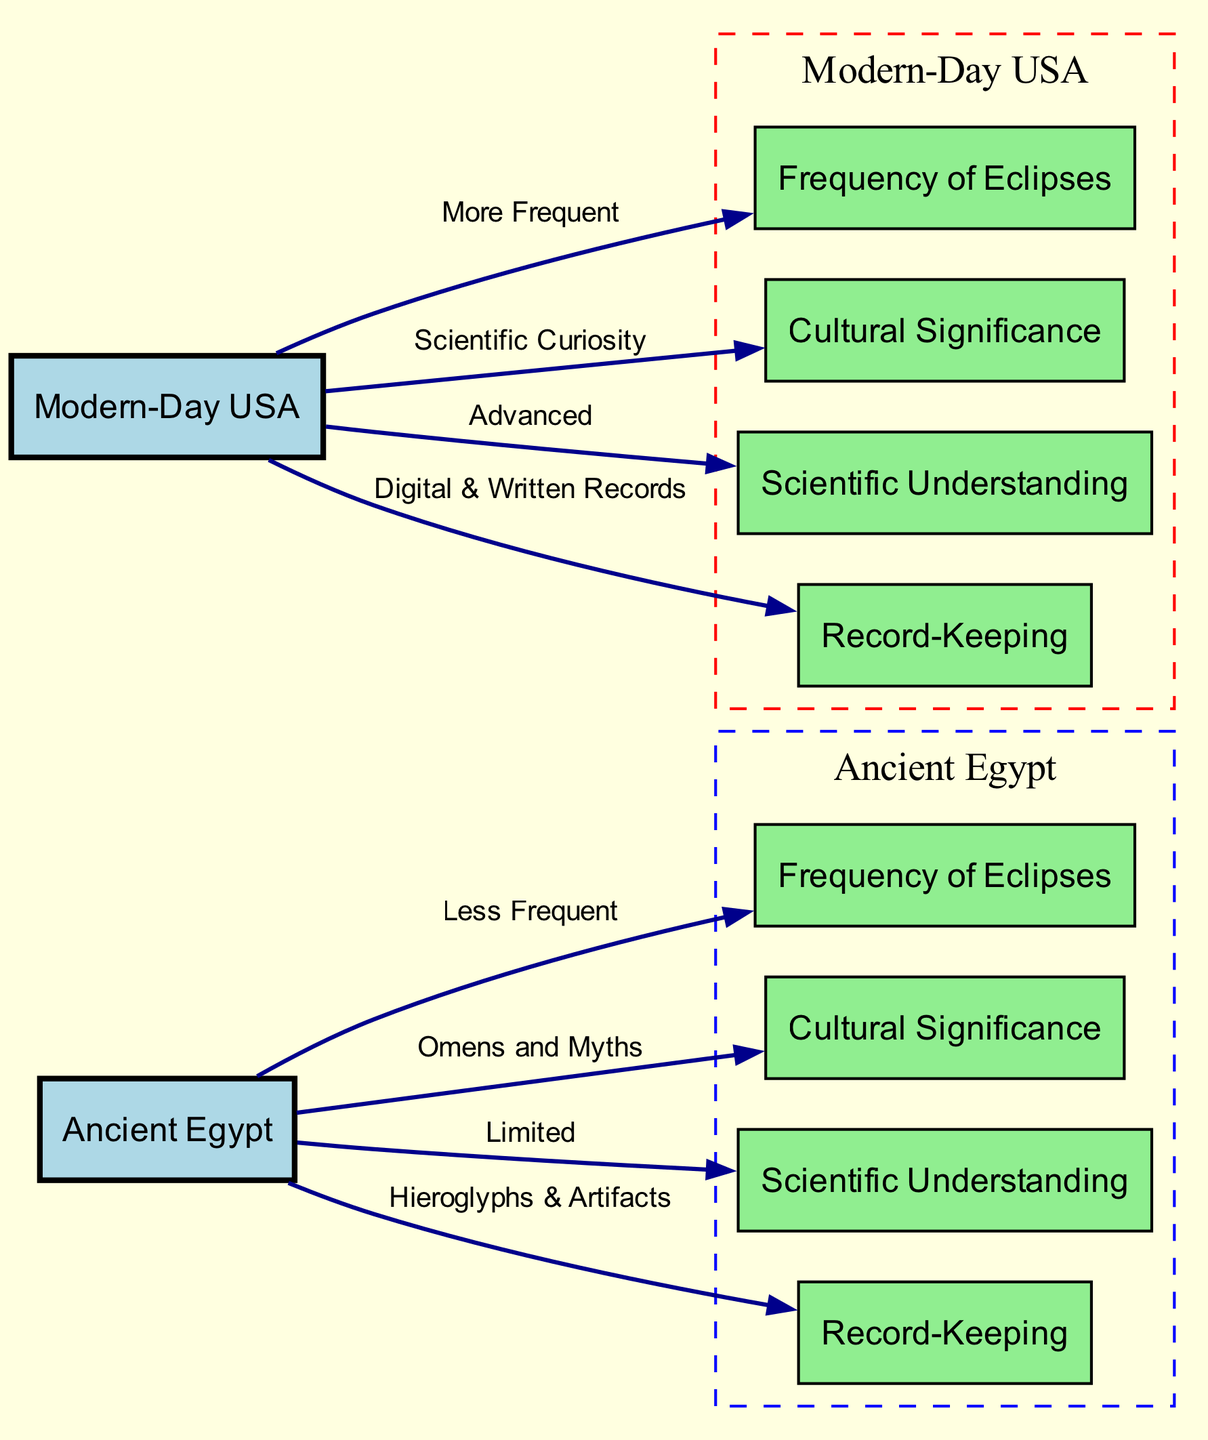what is the cultural significance of solar eclipses in ancient Egypt? The diagram lists that in ancient Egypt, solar eclipses were regarded as "Omens and Myths," indicating a strong cultural interpretation linked to superstition or religious beliefs.
Answer: Omens and Myths how often do solar eclipses occur in modern-day USA compared to ancient Egypt? The diagram shows that solar eclipses are "More Frequent" in modern-day USA than in ancient Egypt where they are "Less Frequent." This directly indicates that the frequency of solar eclipses is higher in the USA.
Answer: More Frequent what type of records were kept for solar eclipses in ancient Egypt? The diagram states that ancient Egypt used "Hieroglyphs & Artifacts" for record-keeping, demonstrating their method of documenting such events.
Answer: Hieroglyphs & Artifacts how is scientific understanding of solar eclipses different between ancient Egypt and modern USA? The edges in the diagram indicate that ancient Egypt had "Limited" scientific understanding, whereas modern USA has "Advanced" scientific understanding, explicitly contrasting the two time periods.
Answer: Advanced what visual feature distinguishes the nodes for Ancient Egypt and Modern-Day USA in the diagram? In the diagram, the nodes representing Ancient Egypt are filled with light blue and are contained in a dashed blue cluster, while the nodes for Modern-Day USA are filled with light green and enclosed in a dashed red cluster. This color-coding visually distinguishes the two periods.
Answer: Light blue and red clusters what is the relationship between ancient Egypt and the frequency of solar eclipses? The arrow labeled "Less Frequent" shows that there is a negative relationship indicating that solar eclipses occur less often in ancient Egypt compared to modern-day scenarios.
Answer: Less Frequent what are the digital record-keeping methods used for solar eclipses in modern-day USA? According to the diagram, modern-day USA utilizes "Digital & Written Records" for maintaining information on solar eclipses, which reflects a modern advancement in documentation methods.
Answer: Digital & Written Records how do the cultural significances of solar eclipses compare between modern-day USA and ancient Egypt? The diagram reveals that ancient Egypt's cultural significance involves "Omens and Myths," while in modern USA, it is driven by "Scientific Curiosity." This comparison indicates a shift from mythological interpretations to scientific inquiry.
Answer: Scientific Curiosity 